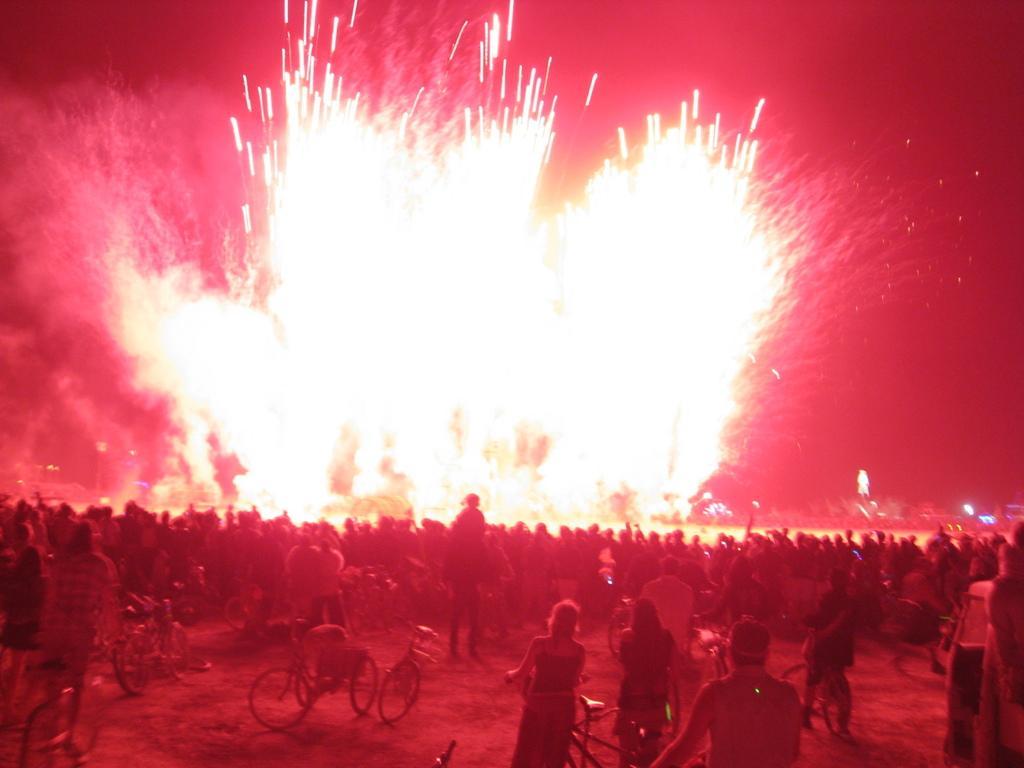In one or two sentences, can you explain what this image depicts? In this image we can see a group of people standing on the ground, some persons are riding bicycles. In the background, we can see some lights and the sky. 